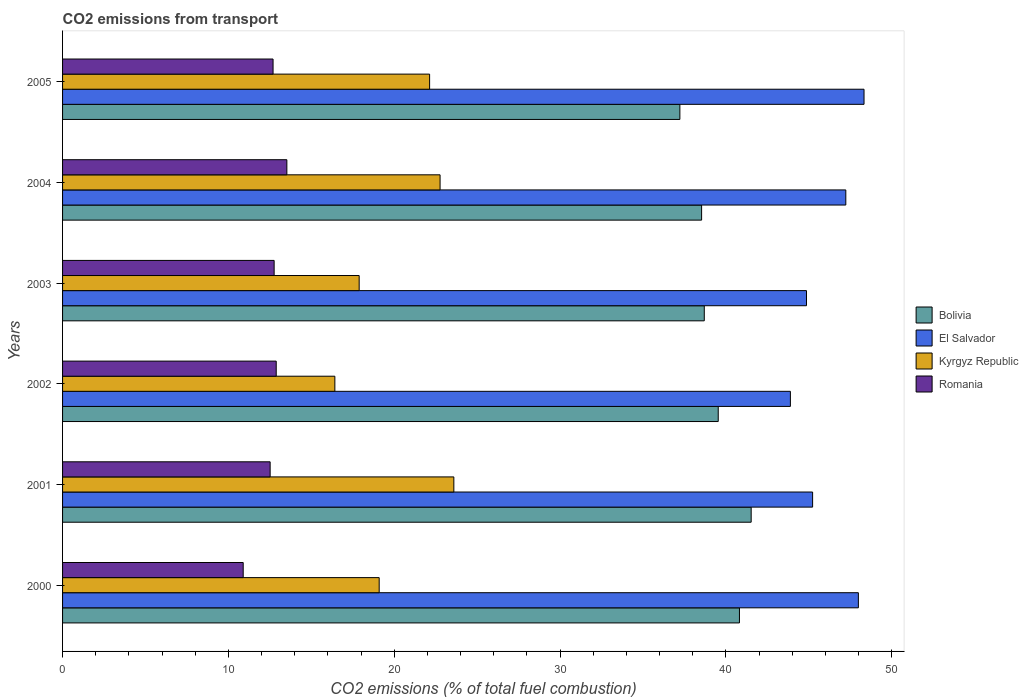How many different coloured bars are there?
Offer a terse response. 4. Are the number of bars per tick equal to the number of legend labels?
Offer a terse response. Yes. Are the number of bars on each tick of the Y-axis equal?
Provide a short and direct response. Yes. How many bars are there on the 6th tick from the top?
Offer a very short reply. 4. What is the label of the 5th group of bars from the top?
Your answer should be very brief. 2001. What is the total CO2 emitted in Romania in 2002?
Offer a terse response. 12.88. Across all years, what is the maximum total CO2 emitted in El Salvador?
Ensure brevity in your answer.  48.33. Across all years, what is the minimum total CO2 emitted in Bolivia?
Offer a terse response. 37.22. What is the total total CO2 emitted in Kyrgyz Republic in the graph?
Your response must be concise. 121.88. What is the difference between the total CO2 emitted in Kyrgyz Republic in 2001 and that in 2005?
Ensure brevity in your answer.  1.46. What is the difference between the total CO2 emitted in Bolivia in 2004 and the total CO2 emitted in Kyrgyz Republic in 2001?
Offer a very short reply. 14.94. What is the average total CO2 emitted in Kyrgyz Republic per year?
Provide a succinct answer. 20.31. In the year 2000, what is the difference between the total CO2 emitted in Kyrgyz Republic and total CO2 emitted in El Salvador?
Your response must be concise. -28.89. In how many years, is the total CO2 emitted in Romania greater than 30 ?
Make the answer very short. 0. What is the ratio of the total CO2 emitted in Bolivia in 2000 to that in 2004?
Keep it short and to the point. 1.06. What is the difference between the highest and the second highest total CO2 emitted in Romania?
Ensure brevity in your answer.  0.64. What is the difference between the highest and the lowest total CO2 emitted in Bolivia?
Ensure brevity in your answer.  4.3. In how many years, is the total CO2 emitted in El Salvador greater than the average total CO2 emitted in El Salvador taken over all years?
Offer a terse response. 3. Is the sum of the total CO2 emitted in Kyrgyz Republic in 2000 and 2003 greater than the maximum total CO2 emitted in El Salvador across all years?
Your response must be concise. No. Is it the case that in every year, the sum of the total CO2 emitted in El Salvador and total CO2 emitted in Romania is greater than the sum of total CO2 emitted in Kyrgyz Republic and total CO2 emitted in Bolivia?
Provide a short and direct response. No. What does the 1st bar from the top in 2004 represents?
Keep it short and to the point. Romania. How many bars are there?
Your answer should be very brief. 24. Does the graph contain grids?
Your answer should be very brief. No. How are the legend labels stacked?
Give a very brief answer. Vertical. What is the title of the graph?
Provide a succinct answer. CO2 emissions from transport. Does "St. Kitts and Nevis" appear as one of the legend labels in the graph?
Offer a terse response. No. What is the label or title of the X-axis?
Keep it short and to the point. CO2 emissions (% of total fuel combustion). What is the label or title of the Y-axis?
Offer a terse response. Years. What is the CO2 emissions (% of total fuel combustion) of Bolivia in 2000?
Make the answer very short. 40.81. What is the CO2 emissions (% of total fuel combustion) in El Salvador in 2000?
Provide a succinct answer. 47.98. What is the CO2 emissions (% of total fuel combustion) in Kyrgyz Republic in 2000?
Ensure brevity in your answer.  19.09. What is the CO2 emissions (% of total fuel combustion) of Romania in 2000?
Your answer should be compact. 10.89. What is the CO2 emissions (% of total fuel combustion) of Bolivia in 2001?
Your answer should be very brief. 41.52. What is the CO2 emissions (% of total fuel combustion) in El Salvador in 2001?
Provide a succinct answer. 45.23. What is the CO2 emissions (% of total fuel combustion) in Kyrgyz Republic in 2001?
Make the answer very short. 23.59. What is the CO2 emissions (% of total fuel combustion) in Romania in 2001?
Provide a short and direct response. 12.52. What is the CO2 emissions (% of total fuel combustion) of Bolivia in 2002?
Provide a short and direct response. 39.53. What is the CO2 emissions (% of total fuel combustion) of El Salvador in 2002?
Make the answer very short. 43.88. What is the CO2 emissions (% of total fuel combustion) of Kyrgyz Republic in 2002?
Your response must be concise. 16.42. What is the CO2 emissions (% of total fuel combustion) of Romania in 2002?
Your answer should be very brief. 12.88. What is the CO2 emissions (% of total fuel combustion) in Bolivia in 2003?
Offer a terse response. 38.69. What is the CO2 emissions (% of total fuel combustion) of El Salvador in 2003?
Keep it short and to the point. 44.86. What is the CO2 emissions (% of total fuel combustion) in Kyrgyz Republic in 2003?
Your response must be concise. 17.88. What is the CO2 emissions (% of total fuel combustion) in Romania in 2003?
Your answer should be compact. 12.76. What is the CO2 emissions (% of total fuel combustion) of Bolivia in 2004?
Ensure brevity in your answer.  38.53. What is the CO2 emissions (% of total fuel combustion) of El Salvador in 2004?
Offer a terse response. 47.23. What is the CO2 emissions (% of total fuel combustion) in Kyrgyz Republic in 2004?
Offer a very short reply. 22.76. What is the CO2 emissions (% of total fuel combustion) in Romania in 2004?
Your answer should be compact. 13.52. What is the CO2 emissions (% of total fuel combustion) in Bolivia in 2005?
Offer a very short reply. 37.22. What is the CO2 emissions (% of total fuel combustion) in El Salvador in 2005?
Keep it short and to the point. 48.33. What is the CO2 emissions (% of total fuel combustion) in Kyrgyz Republic in 2005?
Your answer should be very brief. 22.13. What is the CO2 emissions (% of total fuel combustion) of Romania in 2005?
Offer a very short reply. 12.69. Across all years, what is the maximum CO2 emissions (% of total fuel combustion) of Bolivia?
Provide a succinct answer. 41.52. Across all years, what is the maximum CO2 emissions (% of total fuel combustion) in El Salvador?
Offer a very short reply. 48.33. Across all years, what is the maximum CO2 emissions (% of total fuel combustion) in Kyrgyz Republic?
Your answer should be very brief. 23.59. Across all years, what is the maximum CO2 emissions (% of total fuel combustion) of Romania?
Your answer should be very brief. 13.52. Across all years, what is the minimum CO2 emissions (% of total fuel combustion) of Bolivia?
Make the answer very short. 37.22. Across all years, what is the minimum CO2 emissions (% of total fuel combustion) of El Salvador?
Your response must be concise. 43.88. Across all years, what is the minimum CO2 emissions (% of total fuel combustion) of Kyrgyz Republic?
Your answer should be compact. 16.42. Across all years, what is the minimum CO2 emissions (% of total fuel combustion) in Romania?
Offer a terse response. 10.89. What is the total CO2 emissions (% of total fuel combustion) in Bolivia in the graph?
Provide a short and direct response. 236.32. What is the total CO2 emissions (% of total fuel combustion) in El Salvador in the graph?
Keep it short and to the point. 277.5. What is the total CO2 emissions (% of total fuel combustion) in Kyrgyz Republic in the graph?
Your answer should be very brief. 121.88. What is the total CO2 emissions (% of total fuel combustion) of Romania in the graph?
Offer a terse response. 75.26. What is the difference between the CO2 emissions (% of total fuel combustion) in Bolivia in 2000 and that in 2001?
Provide a short and direct response. -0.71. What is the difference between the CO2 emissions (% of total fuel combustion) in El Salvador in 2000 and that in 2001?
Your answer should be very brief. 2.76. What is the difference between the CO2 emissions (% of total fuel combustion) of Kyrgyz Republic in 2000 and that in 2001?
Give a very brief answer. -4.5. What is the difference between the CO2 emissions (% of total fuel combustion) in Romania in 2000 and that in 2001?
Your answer should be very brief. -1.62. What is the difference between the CO2 emissions (% of total fuel combustion) in Bolivia in 2000 and that in 2002?
Offer a terse response. 1.28. What is the difference between the CO2 emissions (% of total fuel combustion) in El Salvador in 2000 and that in 2002?
Offer a terse response. 4.1. What is the difference between the CO2 emissions (% of total fuel combustion) in Kyrgyz Republic in 2000 and that in 2002?
Your response must be concise. 2.67. What is the difference between the CO2 emissions (% of total fuel combustion) in Romania in 2000 and that in 2002?
Keep it short and to the point. -1.99. What is the difference between the CO2 emissions (% of total fuel combustion) of Bolivia in 2000 and that in 2003?
Ensure brevity in your answer.  2.12. What is the difference between the CO2 emissions (% of total fuel combustion) in El Salvador in 2000 and that in 2003?
Offer a very short reply. 3.13. What is the difference between the CO2 emissions (% of total fuel combustion) of Kyrgyz Republic in 2000 and that in 2003?
Your response must be concise. 1.21. What is the difference between the CO2 emissions (% of total fuel combustion) of Romania in 2000 and that in 2003?
Your answer should be compact. -1.87. What is the difference between the CO2 emissions (% of total fuel combustion) in Bolivia in 2000 and that in 2004?
Keep it short and to the point. 2.28. What is the difference between the CO2 emissions (% of total fuel combustion) of El Salvador in 2000 and that in 2004?
Offer a terse response. 0.76. What is the difference between the CO2 emissions (% of total fuel combustion) in Kyrgyz Republic in 2000 and that in 2004?
Keep it short and to the point. -3.67. What is the difference between the CO2 emissions (% of total fuel combustion) of Romania in 2000 and that in 2004?
Your response must be concise. -2.63. What is the difference between the CO2 emissions (% of total fuel combustion) in Bolivia in 2000 and that in 2005?
Your answer should be very brief. 3.59. What is the difference between the CO2 emissions (% of total fuel combustion) in El Salvador in 2000 and that in 2005?
Your response must be concise. -0.34. What is the difference between the CO2 emissions (% of total fuel combustion) of Kyrgyz Republic in 2000 and that in 2005?
Give a very brief answer. -3.04. What is the difference between the CO2 emissions (% of total fuel combustion) of Romania in 2000 and that in 2005?
Your answer should be very brief. -1.8. What is the difference between the CO2 emissions (% of total fuel combustion) of Bolivia in 2001 and that in 2002?
Your response must be concise. 1.99. What is the difference between the CO2 emissions (% of total fuel combustion) in El Salvador in 2001 and that in 2002?
Give a very brief answer. 1.34. What is the difference between the CO2 emissions (% of total fuel combustion) of Kyrgyz Republic in 2001 and that in 2002?
Give a very brief answer. 7.17. What is the difference between the CO2 emissions (% of total fuel combustion) of Romania in 2001 and that in 2002?
Make the answer very short. -0.37. What is the difference between the CO2 emissions (% of total fuel combustion) in Bolivia in 2001 and that in 2003?
Offer a terse response. 2.83. What is the difference between the CO2 emissions (% of total fuel combustion) of El Salvador in 2001 and that in 2003?
Offer a terse response. 0.37. What is the difference between the CO2 emissions (% of total fuel combustion) in Kyrgyz Republic in 2001 and that in 2003?
Give a very brief answer. 5.71. What is the difference between the CO2 emissions (% of total fuel combustion) in Romania in 2001 and that in 2003?
Your response must be concise. -0.24. What is the difference between the CO2 emissions (% of total fuel combustion) of Bolivia in 2001 and that in 2004?
Offer a terse response. 2.99. What is the difference between the CO2 emissions (% of total fuel combustion) of El Salvador in 2001 and that in 2004?
Give a very brief answer. -2. What is the difference between the CO2 emissions (% of total fuel combustion) in Kyrgyz Republic in 2001 and that in 2004?
Your response must be concise. 0.83. What is the difference between the CO2 emissions (% of total fuel combustion) in Romania in 2001 and that in 2004?
Your response must be concise. -1.01. What is the difference between the CO2 emissions (% of total fuel combustion) of Bolivia in 2001 and that in 2005?
Provide a succinct answer. 4.3. What is the difference between the CO2 emissions (% of total fuel combustion) in El Salvador in 2001 and that in 2005?
Your response must be concise. -3.1. What is the difference between the CO2 emissions (% of total fuel combustion) in Kyrgyz Republic in 2001 and that in 2005?
Your answer should be very brief. 1.46. What is the difference between the CO2 emissions (% of total fuel combustion) in Romania in 2001 and that in 2005?
Make the answer very short. -0.18. What is the difference between the CO2 emissions (% of total fuel combustion) of Bolivia in 2002 and that in 2003?
Ensure brevity in your answer.  0.84. What is the difference between the CO2 emissions (% of total fuel combustion) of El Salvador in 2002 and that in 2003?
Provide a succinct answer. -0.97. What is the difference between the CO2 emissions (% of total fuel combustion) in Kyrgyz Republic in 2002 and that in 2003?
Provide a short and direct response. -1.47. What is the difference between the CO2 emissions (% of total fuel combustion) of Romania in 2002 and that in 2003?
Keep it short and to the point. 0.12. What is the difference between the CO2 emissions (% of total fuel combustion) of El Salvador in 2002 and that in 2004?
Give a very brief answer. -3.34. What is the difference between the CO2 emissions (% of total fuel combustion) of Kyrgyz Republic in 2002 and that in 2004?
Provide a succinct answer. -6.34. What is the difference between the CO2 emissions (% of total fuel combustion) of Romania in 2002 and that in 2004?
Offer a very short reply. -0.64. What is the difference between the CO2 emissions (% of total fuel combustion) in Bolivia in 2002 and that in 2005?
Offer a terse response. 2.31. What is the difference between the CO2 emissions (% of total fuel combustion) in El Salvador in 2002 and that in 2005?
Provide a succinct answer. -4.44. What is the difference between the CO2 emissions (% of total fuel combustion) in Kyrgyz Republic in 2002 and that in 2005?
Ensure brevity in your answer.  -5.71. What is the difference between the CO2 emissions (% of total fuel combustion) of Romania in 2002 and that in 2005?
Your answer should be very brief. 0.19. What is the difference between the CO2 emissions (% of total fuel combustion) in Bolivia in 2003 and that in 2004?
Make the answer very short. 0.16. What is the difference between the CO2 emissions (% of total fuel combustion) of El Salvador in 2003 and that in 2004?
Make the answer very short. -2.37. What is the difference between the CO2 emissions (% of total fuel combustion) of Kyrgyz Republic in 2003 and that in 2004?
Provide a succinct answer. -4.88. What is the difference between the CO2 emissions (% of total fuel combustion) in Romania in 2003 and that in 2004?
Make the answer very short. -0.77. What is the difference between the CO2 emissions (% of total fuel combustion) in Bolivia in 2003 and that in 2005?
Provide a succinct answer. 1.47. What is the difference between the CO2 emissions (% of total fuel combustion) in El Salvador in 2003 and that in 2005?
Ensure brevity in your answer.  -3.47. What is the difference between the CO2 emissions (% of total fuel combustion) of Kyrgyz Republic in 2003 and that in 2005?
Provide a short and direct response. -4.25. What is the difference between the CO2 emissions (% of total fuel combustion) of Romania in 2003 and that in 2005?
Make the answer very short. 0.07. What is the difference between the CO2 emissions (% of total fuel combustion) of Bolivia in 2004 and that in 2005?
Offer a very short reply. 1.31. What is the difference between the CO2 emissions (% of total fuel combustion) of El Salvador in 2004 and that in 2005?
Your answer should be compact. -1.1. What is the difference between the CO2 emissions (% of total fuel combustion) of Kyrgyz Republic in 2004 and that in 2005?
Keep it short and to the point. 0.63. What is the difference between the CO2 emissions (% of total fuel combustion) of Romania in 2004 and that in 2005?
Give a very brief answer. 0.83. What is the difference between the CO2 emissions (% of total fuel combustion) in Bolivia in 2000 and the CO2 emissions (% of total fuel combustion) in El Salvador in 2001?
Your answer should be very brief. -4.41. What is the difference between the CO2 emissions (% of total fuel combustion) of Bolivia in 2000 and the CO2 emissions (% of total fuel combustion) of Kyrgyz Republic in 2001?
Your answer should be compact. 17.22. What is the difference between the CO2 emissions (% of total fuel combustion) of Bolivia in 2000 and the CO2 emissions (% of total fuel combustion) of Romania in 2001?
Your response must be concise. 28.3. What is the difference between the CO2 emissions (% of total fuel combustion) in El Salvador in 2000 and the CO2 emissions (% of total fuel combustion) in Kyrgyz Republic in 2001?
Provide a succinct answer. 24.39. What is the difference between the CO2 emissions (% of total fuel combustion) in El Salvador in 2000 and the CO2 emissions (% of total fuel combustion) in Romania in 2001?
Provide a succinct answer. 35.47. What is the difference between the CO2 emissions (% of total fuel combustion) in Kyrgyz Republic in 2000 and the CO2 emissions (% of total fuel combustion) in Romania in 2001?
Give a very brief answer. 6.57. What is the difference between the CO2 emissions (% of total fuel combustion) in Bolivia in 2000 and the CO2 emissions (% of total fuel combustion) in El Salvador in 2002?
Keep it short and to the point. -3.07. What is the difference between the CO2 emissions (% of total fuel combustion) of Bolivia in 2000 and the CO2 emissions (% of total fuel combustion) of Kyrgyz Republic in 2002?
Your answer should be very brief. 24.4. What is the difference between the CO2 emissions (% of total fuel combustion) of Bolivia in 2000 and the CO2 emissions (% of total fuel combustion) of Romania in 2002?
Your answer should be compact. 27.93. What is the difference between the CO2 emissions (% of total fuel combustion) of El Salvador in 2000 and the CO2 emissions (% of total fuel combustion) of Kyrgyz Republic in 2002?
Give a very brief answer. 31.57. What is the difference between the CO2 emissions (% of total fuel combustion) of El Salvador in 2000 and the CO2 emissions (% of total fuel combustion) of Romania in 2002?
Ensure brevity in your answer.  35.1. What is the difference between the CO2 emissions (% of total fuel combustion) in Kyrgyz Republic in 2000 and the CO2 emissions (% of total fuel combustion) in Romania in 2002?
Your response must be concise. 6.21. What is the difference between the CO2 emissions (% of total fuel combustion) of Bolivia in 2000 and the CO2 emissions (% of total fuel combustion) of El Salvador in 2003?
Give a very brief answer. -4.04. What is the difference between the CO2 emissions (% of total fuel combustion) of Bolivia in 2000 and the CO2 emissions (% of total fuel combustion) of Kyrgyz Republic in 2003?
Your answer should be very brief. 22.93. What is the difference between the CO2 emissions (% of total fuel combustion) of Bolivia in 2000 and the CO2 emissions (% of total fuel combustion) of Romania in 2003?
Provide a succinct answer. 28.06. What is the difference between the CO2 emissions (% of total fuel combustion) in El Salvador in 2000 and the CO2 emissions (% of total fuel combustion) in Kyrgyz Republic in 2003?
Provide a succinct answer. 30.1. What is the difference between the CO2 emissions (% of total fuel combustion) of El Salvador in 2000 and the CO2 emissions (% of total fuel combustion) of Romania in 2003?
Ensure brevity in your answer.  35.23. What is the difference between the CO2 emissions (% of total fuel combustion) in Kyrgyz Republic in 2000 and the CO2 emissions (% of total fuel combustion) in Romania in 2003?
Offer a very short reply. 6.33. What is the difference between the CO2 emissions (% of total fuel combustion) in Bolivia in 2000 and the CO2 emissions (% of total fuel combustion) in El Salvador in 2004?
Your response must be concise. -6.41. What is the difference between the CO2 emissions (% of total fuel combustion) in Bolivia in 2000 and the CO2 emissions (% of total fuel combustion) in Kyrgyz Republic in 2004?
Provide a short and direct response. 18.05. What is the difference between the CO2 emissions (% of total fuel combustion) of Bolivia in 2000 and the CO2 emissions (% of total fuel combustion) of Romania in 2004?
Provide a succinct answer. 27.29. What is the difference between the CO2 emissions (% of total fuel combustion) in El Salvador in 2000 and the CO2 emissions (% of total fuel combustion) in Kyrgyz Republic in 2004?
Offer a very short reply. 25.22. What is the difference between the CO2 emissions (% of total fuel combustion) of El Salvador in 2000 and the CO2 emissions (% of total fuel combustion) of Romania in 2004?
Give a very brief answer. 34.46. What is the difference between the CO2 emissions (% of total fuel combustion) of Kyrgyz Republic in 2000 and the CO2 emissions (% of total fuel combustion) of Romania in 2004?
Offer a very short reply. 5.57. What is the difference between the CO2 emissions (% of total fuel combustion) of Bolivia in 2000 and the CO2 emissions (% of total fuel combustion) of El Salvador in 2005?
Ensure brevity in your answer.  -7.51. What is the difference between the CO2 emissions (% of total fuel combustion) in Bolivia in 2000 and the CO2 emissions (% of total fuel combustion) in Kyrgyz Republic in 2005?
Your answer should be very brief. 18.68. What is the difference between the CO2 emissions (% of total fuel combustion) in Bolivia in 2000 and the CO2 emissions (% of total fuel combustion) in Romania in 2005?
Make the answer very short. 28.12. What is the difference between the CO2 emissions (% of total fuel combustion) in El Salvador in 2000 and the CO2 emissions (% of total fuel combustion) in Kyrgyz Republic in 2005?
Provide a short and direct response. 25.85. What is the difference between the CO2 emissions (% of total fuel combustion) of El Salvador in 2000 and the CO2 emissions (% of total fuel combustion) of Romania in 2005?
Your answer should be very brief. 35.29. What is the difference between the CO2 emissions (% of total fuel combustion) of Kyrgyz Republic in 2000 and the CO2 emissions (% of total fuel combustion) of Romania in 2005?
Your answer should be compact. 6.4. What is the difference between the CO2 emissions (% of total fuel combustion) in Bolivia in 2001 and the CO2 emissions (% of total fuel combustion) in El Salvador in 2002?
Your response must be concise. -2.36. What is the difference between the CO2 emissions (% of total fuel combustion) of Bolivia in 2001 and the CO2 emissions (% of total fuel combustion) of Kyrgyz Republic in 2002?
Your answer should be compact. 25.1. What is the difference between the CO2 emissions (% of total fuel combustion) in Bolivia in 2001 and the CO2 emissions (% of total fuel combustion) in Romania in 2002?
Make the answer very short. 28.64. What is the difference between the CO2 emissions (% of total fuel combustion) in El Salvador in 2001 and the CO2 emissions (% of total fuel combustion) in Kyrgyz Republic in 2002?
Your answer should be very brief. 28.81. What is the difference between the CO2 emissions (% of total fuel combustion) of El Salvador in 2001 and the CO2 emissions (% of total fuel combustion) of Romania in 2002?
Offer a terse response. 32.34. What is the difference between the CO2 emissions (% of total fuel combustion) in Kyrgyz Republic in 2001 and the CO2 emissions (% of total fuel combustion) in Romania in 2002?
Make the answer very short. 10.71. What is the difference between the CO2 emissions (% of total fuel combustion) in Bolivia in 2001 and the CO2 emissions (% of total fuel combustion) in El Salvador in 2003?
Give a very brief answer. -3.34. What is the difference between the CO2 emissions (% of total fuel combustion) in Bolivia in 2001 and the CO2 emissions (% of total fuel combustion) in Kyrgyz Republic in 2003?
Make the answer very short. 23.64. What is the difference between the CO2 emissions (% of total fuel combustion) in Bolivia in 2001 and the CO2 emissions (% of total fuel combustion) in Romania in 2003?
Ensure brevity in your answer.  28.76. What is the difference between the CO2 emissions (% of total fuel combustion) of El Salvador in 2001 and the CO2 emissions (% of total fuel combustion) of Kyrgyz Republic in 2003?
Your answer should be compact. 27.34. What is the difference between the CO2 emissions (% of total fuel combustion) of El Salvador in 2001 and the CO2 emissions (% of total fuel combustion) of Romania in 2003?
Your response must be concise. 32.47. What is the difference between the CO2 emissions (% of total fuel combustion) in Kyrgyz Republic in 2001 and the CO2 emissions (% of total fuel combustion) in Romania in 2003?
Provide a short and direct response. 10.83. What is the difference between the CO2 emissions (% of total fuel combustion) in Bolivia in 2001 and the CO2 emissions (% of total fuel combustion) in El Salvador in 2004?
Ensure brevity in your answer.  -5.71. What is the difference between the CO2 emissions (% of total fuel combustion) of Bolivia in 2001 and the CO2 emissions (% of total fuel combustion) of Kyrgyz Republic in 2004?
Your answer should be very brief. 18.76. What is the difference between the CO2 emissions (% of total fuel combustion) of Bolivia in 2001 and the CO2 emissions (% of total fuel combustion) of Romania in 2004?
Make the answer very short. 28. What is the difference between the CO2 emissions (% of total fuel combustion) in El Salvador in 2001 and the CO2 emissions (% of total fuel combustion) in Kyrgyz Republic in 2004?
Offer a terse response. 22.46. What is the difference between the CO2 emissions (% of total fuel combustion) of El Salvador in 2001 and the CO2 emissions (% of total fuel combustion) of Romania in 2004?
Offer a very short reply. 31.7. What is the difference between the CO2 emissions (% of total fuel combustion) in Kyrgyz Republic in 2001 and the CO2 emissions (% of total fuel combustion) in Romania in 2004?
Your response must be concise. 10.07. What is the difference between the CO2 emissions (% of total fuel combustion) of Bolivia in 2001 and the CO2 emissions (% of total fuel combustion) of El Salvador in 2005?
Provide a short and direct response. -6.8. What is the difference between the CO2 emissions (% of total fuel combustion) in Bolivia in 2001 and the CO2 emissions (% of total fuel combustion) in Kyrgyz Republic in 2005?
Ensure brevity in your answer.  19.39. What is the difference between the CO2 emissions (% of total fuel combustion) of Bolivia in 2001 and the CO2 emissions (% of total fuel combustion) of Romania in 2005?
Your answer should be very brief. 28.83. What is the difference between the CO2 emissions (% of total fuel combustion) of El Salvador in 2001 and the CO2 emissions (% of total fuel combustion) of Kyrgyz Republic in 2005?
Ensure brevity in your answer.  23.09. What is the difference between the CO2 emissions (% of total fuel combustion) in El Salvador in 2001 and the CO2 emissions (% of total fuel combustion) in Romania in 2005?
Your answer should be very brief. 32.53. What is the difference between the CO2 emissions (% of total fuel combustion) in Kyrgyz Republic in 2001 and the CO2 emissions (% of total fuel combustion) in Romania in 2005?
Your answer should be compact. 10.9. What is the difference between the CO2 emissions (% of total fuel combustion) of Bolivia in 2002 and the CO2 emissions (% of total fuel combustion) of El Salvador in 2003?
Ensure brevity in your answer.  -5.32. What is the difference between the CO2 emissions (% of total fuel combustion) in Bolivia in 2002 and the CO2 emissions (% of total fuel combustion) in Kyrgyz Republic in 2003?
Give a very brief answer. 21.65. What is the difference between the CO2 emissions (% of total fuel combustion) of Bolivia in 2002 and the CO2 emissions (% of total fuel combustion) of Romania in 2003?
Keep it short and to the point. 26.78. What is the difference between the CO2 emissions (% of total fuel combustion) of El Salvador in 2002 and the CO2 emissions (% of total fuel combustion) of Kyrgyz Republic in 2003?
Give a very brief answer. 26. What is the difference between the CO2 emissions (% of total fuel combustion) in El Salvador in 2002 and the CO2 emissions (% of total fuel combustion) in Romania in 2003?
Your answer should be very brief. 31.13. What is the difference between the CO2 emissions (% of total fuel combustion) in Kyrgyz Republic in 2002 and the CO2 emissions (% of total fuel combustion) in Romania in 2003?
Give a very brief answer. 3.66. What is the difference between the CO2 emissions (% of total fuel combustion) in Bolivia in 2002 and the CO2 emissions (% of total fuel combustion) in El Salvador in 2004?
Ensure brevity in your answer.  -7.69. What is the difference between the CO2 emissions (% of total fuel combustion) of Bolivia in 2002 and the CO2 emissions (% of total fuel combustion) of Kyrgyz Republic in 2004?
Keep it short and to the point. 16.77. What is the difference between the CO2 emissions (% of total fuel combustion) of Bolivia in 2002 and the CO2 emissions (% of total fuel combustion) of Romania in 2004?
Make the answer very short. 26.01. What is the difference between the CO2 emissions (% of total fuel combustion) of El Salvador in 2002 and the CO2 emissions (% of total fuel combustion) of Kyrgyz Republic in 2004?
Ensure brevity in your answer.  21.12. What is the difference between the CO2 emissions (% of total fuel combustion) in El Salvador in 2002 and the CO2 emissions (% of total fuel combustion) in Romania in 2004?
Your answer should be compact. 30.36. What is the difference between the CO2 emissions (% of total fuel combustion) in Kyrgyz Republic in 2002 and the CO2 emissions (% of total fuel combustion) in Romania in 2004?
Keep it short and to the point. 2.89. What is the difference between the CO2 emissions (% of total fuel combustion) in Bolivia in 2002 and the CO2 emissions (% of total fuel combustion) in El Salvador in 2005?
Provide a succinct answer. -8.79. What is the difference between the CO2 emissions (% of total fuel combustion) of Bolivia in 2002 and the CO2 emissions (% of total fuel combustion) of Kyrgyz Republic in 2005?
Offer a terse response. 17.4. What is the difference between the CO2 emissions (% of total fuel combustion) in Bolivia in 2002 and the CO2 emissions (% of total fuel combustion) in Romania in 2005?
Offer a very short reply. 26.84. What is the difference between the CO2 emissions (% of total fuel combustion) in El Salvador in 2002 and the CO2 emissions (% of total fuel combustion) in Kyrgyz Republic in 2005?
Offer a terse response. 21.75. What is the difference between the CO2 emissions (% of total fuel combustion) in El Salvador in 2002 and the CO2 emissions (% of total fuel combustion) in Romania in 2005?
Offer a terse response. 31.19. What is the difference between the CO2 emissions (% of total fuel combustion) in Kyrgyz Republic in 2002 and the CO2 emissions (% of total fuel combustion) in Romania in 2005?
Ensure brevity in your answer.  3.73. What is the difference between the CO2 emissions (% of total fuel combustion) in Bolivia in 2003 and the CO2 emissions (% of total fuel combustion) in El Salvador in 2004?
Your response must be concise. -8.53. What is the difference between the CO2 emissions (% of total fuel combustion) in Bolivia in 2003 and the CO2 emissions (% of total fuel combustion) in Kyrgyz Republic in 2004?
Keep it short and to the point. 15.93. What is the difference between the CO2 emissions (% of total fuel combustion) in Bolivia in 2003 and the CO2 emissions (% of total fuel combustion) in Romania in 2004?
Give a very brief answer. 25.17. What is the difference between the CO2 emissions (% of total fuel combustion) in El Salvador in 2003 and the CO2 emissions (% of total fuel combustion) in Kyrgyz Republic in 2004?
Your answer should be compact. 22.09. What is the difference between the CO2 emissions (% of total fuel combustion) of El Salvador in 2003 and the CO2 emissions (% of total fuel combustion) of Romania in 2004?
Provide a short and direct response. 31.33. What is the difference between the CO2 emissions (% of total fuel combustion) of Kyrgyz Republic in 2003 and the CO2 emissions (% of total fuel combustion) of Romania in 2004?
Keep it short and to the point. 4.36. What is the difference between the CO2 emissions (% of total fuel combustion) of Bolivia in 2003 and the CO2 emissions (% of total fuel combustion) of El Salvador in 2005?
Ensure brevity in your answer.  -9.63. What is the difference between the CO2 emissions (% of total fuel combustion) of Bolivia in 2003 and the CO2 emissions (% of total fuel combustion) of Kyrgyz Republic in 2005?
Offer a terse response. 16.56. What is the difference between the CO2 emissions (% of total fuel combustion) in Bolivia in 2003 and the CO2 emissions (% of total fuel combustion) in Romania in 2005?
Keep it short and to the point. 26. What is the difference between the CO2 emissions (% of total fuel combustion) in El Salvador in 2003 and the CO2 emissions (% of total fuel combustion) in Kyrgyz Republic in 2005?
Keep it short and to the point. 22.73. What is the difference between the CO2 emissions (% of total fuel combustion) in El Salvador in 2003 and the CO2 emissions (% of total fuel combustion) in Romania in 2005?
Ensure brevity in your answer.  32.16. What is the difference between the CO2 emissions (% of total fuel combustion) in Kyrgyz Republic in 2003 and the CO2 emissions (% of total fuel combustion) in Romania in 2005?
Your response must be concise. 5.19. What is the difference between the CO2 emissions (% of total fuel combustion) in Bolivia in 2004 and the CO2 emissions (% of total fuel combustion) in El Salvador in 2005?
Keep it short and to the point. -9.79. What is the difference between the CO2 emissions (% of total fuel combustion) in Bolivia in 2004 and the CO2 emissions (% of total fuel combustion) in Kyrgyz Republic in 2005?
Keep it short and to the point. 16.4. What is the difference between the CO2 emissions (% of total fuel combustion) in Bolivia in 2004 and the CO2 emissions (% of total fuel combustion) in Romania in 2005?
Your answer should be compact. 25.84. What is the difference between the CO2 emissions (% of total fuel combustion) in El Salvador in 2004 and the CO2 emissions (% of total fuel combustion) in Kyrgyz Republic in 2005?
Offer a terse response. 25.1. What is the difference between the CO2 emissions (% of total fuel combustion) of El Salvador in 2004 and the CO2 emissions (% of total fuel combustion) of Romania in 2005?
Offer a terse response. 34.53. What is the difference between the CO2 emissions (% of total fuel combustion) of Kyrgyz Republic in 2004 and the CO2 emissions (% of total fuel combustion) of Romania in 2005?
Give a very brief answer. 10.07. What is the average CO2 emissions (% of total fuel combustion) of Bolivia per year?
Your response must be concise. 39.39. What is the average CO2 emissions (% of total fuel combustion) of El Salvador per year?
Offer a terse response. 46.25. What is the average CO2 emissions (% of total fuel combustion) in Kyrgyz Republic per year?
Your answer should be very brief. 20.31. What is the average CO2 emissions (% of total fuel combustion) of Romania per year?
Make the answer very short. 12.54. In the year 2000, what is the difference between the CO2 emissions (% of total fuel combustion) in Bolivia and CO2 emissions (% of total fuel combustion) in El Salvador?
Offer a terse response. -7.17. In the year 2000, what is the difference between the CO2 emissions (% of total fuel combustion) in Bolivia and CO2 emissions (% of total fuel combustion) in Kyrgyz Republic?
Offer a very short reply. 21.72. In the year 2000, what is the difference between the CO2 emissions (% of total fuel combustion) in Bolivia and CO2 emissions (% of total fuel combustion) in Romania?
Keep it short and to the point. 29.92. In the year 2000, what is the difference between the CO2 emissions (% of total fuel combustion) of El Salvador and CO2 emissions (% of total fuel combustion) of Kyrgyz Republic?
Keep it short and to the point. 28.89. In the year 2000, what is the difference between the CO2 emissions (% of total fuel combustion) in El Salvador and CO2 emissions (% of total fuel combustion) in Romania?
Ensure brevity in your answer.  37.09. In the year 2000, what is the difference between the CO2 emissions (% of total fuel combustion) of Kyrgyz Republic and CO2 emissions (% of total fuel combustion) of Romania?
Offer a very short reply. 8.2. In the year 2001, what is the difference between the CO2 emissions (% of total fuel combustion) of Bolivia and CO2 emissions (% of total fuel combustion) of El Salvador?
Your answer should be very brief. -3.7. In the year 2001, what is the difference between the CO2 emissions (% of total fuel combustion) of Bolivia and CO2 emissions (% of total fuel combustion) of Kyrgyz Republic?
Your response must be concise. 17.93. In the year 2001, what is the difference between the CO2 emissions (% of total fuel combustion) of Bolivia and CO2 emissions (% of total fuel combustion) of Romania?
Ensure brevity in your answer.  29. In the year 2001, what is the difference between the CO2 emissions (% of total fuel combustion) in El Salvador and CO2 emissions (% of total fuel combustion) in Kyrgyz Republic?
Your response must be concise. 21.63. In the year 2001, what is the difference between the CO2 emissions (% of total fuel combustion) in El Salvador and CO2 emissions (% of total fuel combustion) in Romania?
Your answer should be very brief. 32.71. In the year 2001, what is the difference between the CO2 emissions (% of total fuel combustion) in Kyrgyz Republic and CO2 emissions (% of total fuel combustion) in Romania?
Make the answer very short. 11.08. In the year 2002, what is the difference between the CO2 emissions (% of total fuel combustion) in Bolivia and CO2 emissions (% of total fuel combustion) in El Salvador?
Give a very brief answer. -4.35. In the year 2002, what is the difference between the CO2 emissions (% of total fuel combustion) of Bolivia and CO2 emissions (% of total fuel combustion) of Kyrgyz Republic?
Your response must be concise. 23.12. In the year 2002, what is the difference between the CO2 emissions (% of total fuel combustion) in Bolivia and CO2 emissions (% of total fuel combustion) in Romania?
Your response must be concise. 26.65. In the year 2002, what is the difference between the CO2 emissions (% of total fuel combustion) in El Salvador and CO2 emissions (% of total fuel combustion) in Kyrgyz Republic?
Provide a succinct answer. 27.47. In the year 2002, what is the difference between the CO2 emissions (% of total fuel combustion) in El Salvador and CO2 emissions (% of total fuel combustion) in Romania?
Provide a short and direct response. 31. In the year 2002, what is the difference between the CO2 emissions (% of total fuel combustion) in Kyrgyz Republic and CO2 emissions (% of total fuel combustion) in Romania?
Give a very brief answer. 3.54. In the year 2003, what is the difference between the CO2 emissions (% of total fuel combustion) of Bolivia and CO2 emissions (% of total fuel combustion) of El Salvador?
Keep it short and to the point. -6.16. In the year 2003, what is the difference between the CO2 emissions (% of total fuel combustion) of Bolivia and CO2 emissions (% of total fuel combustion) of Kyrgyz Republic?
Your answer should be very brief. 20.81. In the year 2003, what is the difference between the CO2 emissions (% of total fuel combustion) of Bolivia and CO2 emissions (% of total fuel combustion) of Romania?
Your answer should be very brief. 25.94. In the year 2003, what is the difference between the CO2 emissions (% of total fuel combustion) in El Salvador and CO2 emissions (% of total fuel combustion) in Kyrgyz Republic?
Make the answer very short. 26.97. In the year 2003, what is the difference between the CO2 emissions (% of total fuel combustion) in El Salvador and CO2 emissions (% of total fuel combustion) in Romania?
Make the answer very short. 32.1. In the year 2003, what is the difference between the CO2 emissions (% of total fuel combustion) of Kyrgyz Republic and CO2 emissions (% of total fuel combustion) of Romania?
Ensure brevity in your answer.  5.13. In the year 2004, what is the difference between the CO2 emissions (% of total fuel combustion) of Bolivia and CO2 emissions (% of total fuel combustion) of El Salvador?
Your answer should be very brief. -8.69. In the year 2004, what is the difference between the CO2 emissions (% of total fuel combustion) in Bolivia and CO2 emissions (% of total fuel combustion) in Kyrgyz Republic?
Ensure brevity in your answer.  15.77. In the year 2004, what is the difference between the CO2 emissions (% of total fuel combustion) in Bolivia and CO2 emissions (% of total fuel combustion) in Romania?
Give a very brief answer. 25.01. In the year 2004, what is the difference between the CO2 emissions (% of total fuel combustion) of El Salvador and CO2 emissions (% of total fuel combustion) of Kyrgyz Republic?
Your response must be concise. 24.46. In the year 2004, what is the difference between the CO2 emissions (% of total fuel combustion) in El Salvador and CO2 emissions (% of total fuel combustion) in Romania?
Give a very brief answer. 33.7. In the year 2004, what is the difference between the CO2 emissions (% of total fuel combustion) in Kyrgyz Republic and CO2 emissions (% of total fuel combustion) in Romania?
Make the answer very short. 9.24. In the year 2005, what is the difference between the CO2 emissions (% of total fuel combustion) of Bolivia and CO2 emissions (% of total fuel combustion) of El Salvador?
Ensure brevity in your answer.  -11.1. In the year 2005, what is the difference between the CO2 emissions (% of total fuel combustion) of Bolivia and CO2 emissions (% of total fuel combustion) of Kyrgyz Republic?
Provide a short and direct response. 15.09. In the year 2005, what is the difference between the CO2 emissions (% of total fuel combustion) of Bolivia and CO2 emissions (% of total fuel combustion) of Romania?
Offer a terse response. 24.53. In the year 2005, what is the difference between the CO2 emissions (% of total fuel combustion) of El Salvador and CO2 emissions (% of total fuel combustion) of Kyrgyz Republic?
Offer a very short reply. 26.19. In the year 2005, what is the difference between the CO2 emissions (% of total fuel combustion) in El Salvador and CO2 emissions (% of total fuel combustion) in Romania?
Offer a very short reply. 35.63. In the year 2005, what is the difference between the CO2 emissions (% of total fuel combustion) in Kyrgyz Republic and CO2 emissions (% of total fuel combustion) in Romania?
Offer a very short reply. 9.44. What is the ratio of the CO2 emissions (% of total fuel combustion) in Bolivia in 2000 to that in 2001?
Provide a succinct answer. 0.98. What is the ratio of the CO2 emissions (% of total fuel combustion) in El Salvador in 2000 to that in 2001?
Offer a very short reply. 1.06. What is the ratio of the CO2 emissions (% of total fuel combustion) of Kyrgyz Republic in 2000 to that in 2001?
Provide a succinct answer. 0.81. What is the ratio of the CO2 emissions (% of total fuel combustion) of Romania in 2000 to that in 2001?
Ensure brevity in your answer.  0.87. What is the ratio of the CO2 emissions (% of total fuel combustion) of Bolivia in 2000 to that in 2002?
Provide a short and direct response. 1.03. What is the ratio of the CO2 emissions (% of total fuel combustion) in El Salvador in 2000 to that in 2002?
Ensure brevity in your answer.  1.09. What is the ratio of the CO2 emissions (% of total fuel combustion) of Kyrgyz Republic in 2000 to that in 2002?
Provide a succinct answer. 1.16. What is the ratio of the CO2 emissions (% of total fuel combustion) in Romania in 2000 to that in 2002?
Offer a terse response. 0.85. What is the ratio of the CO2 emissions (% of total fuel combustion) in Bolivia in 2000 to that in 2003?
Offer a very short reply. 1.05. What is the ratio of the CO2 emissions (% of total fuel combustion) in El Salvador in 2000 to that in 2003?
Keep it short and to the point. 1.07. What is the ratio of the CO2 emissions (% of total fuel combustion) of Kyrgyz Republic in 2000 to that in 2003?
Provide a succinct answer. 1.07. What is the ratio of the CO2 emissions (% of total fuel combustion) in Romania in 2000 to that in 2003?
Ensure brevity in your answer.  0.85. What is the ratio of the CO2 emissions (% of total fuel combustion) in Bolivia in 2000 to that in 2004?
Give a very brief answer. 1.06. What is the ratio of the CO2 emissions (% of total fuel combustion) in El Salvador in 2000 to that in 2004?
Your response must be concise. 1.02. What is the ratio of the CO2 emissions (% of total fuel combustion) of Kyrgyz Republic in 2000 to that in 2004?
Ensure brevity in your answer.  0.84. What is the ratio of the CO2 emissions (% of total fuel combustion) of Romania in 2000 to that in 2004?
Give a very brief answer. 0.81. What is the ratio of the CO2 emissions (% of total fuel combustion) in Bolivia in 2000 to that in 2005?
Make the answer very short. 1.1. What is the ratio of the CO2 emissions (% of total fuel combustion) of Kyrgyz Republic in 2000 to that in 2005?
Keep it short and to the point. 0.86. What is the ratio of the CO2 emissions (% of total fuel combustion) of Romania in 2000 to that in 2005?
Offer a very short reply. 0.86. What is the ratio of the CO2 emissions (% of total fuel combustion) in Bolivia in 2001 to that in 2002?
Your answer should be compact. 1.05. What is the ratio of the CO2 emissions (% of total fuel combustion) in El Salvador in 2001 to that in 2002?
Your answer should be compact. 1.03. What is the ratio of the CO2 emissions (% of total fuel combustion) in Kyrgyz Republic in 2001 to that in 2002?
Provide a short and direct response. 1.44. What is the ratio of the CO2 emissions (% of total fuel combustion) of Romania in 2001 to that in 2002?
Provide a succinct answer. 0.97. What is the ratio of the CO2 emissions (% of total fuel combustion) in Bolivia in 2001 to that in 2003?
Give a very brief answer. 1.07. What is the ratio of the CO2 emissions (% of total fuel combustion) in El Salvador in 2001 to that in 2003?
Provide a succinct answer. 1.01. What is the ratio of the CO2 emissions (% of total fuel combustion) in Kyrgyz Republic in 2001 to that in 2003?
Offer a very short reply. 1.32. What is the ratio of the CO2 emissions (% of total fuel combustion) in Romania in 2001 to that in 2003?
Ensure brevity in your answer.  0.98. What is the ratio of the CO2 emissions (% of total fuel combustion) of Bolivia in 2001 to that in 2004?
Give a very brief answer. 1.08. What is the ratio of the CO2 emissions (% of total fuel combustion) of El Salvador in 2001 to that in 2004?
Offer a terse response. 0.96. What is the ratio of the CO2 emissions (% of total fuel combustion) of Kyrgyz Republic in 2001 to that in 2004?
Give a very brief answer. 1.04. What is the ratio of the CO2 emissions (% of total fuel combustion) of Romania in 2001 to that in 2004?
Your answer should be very brief. 0.93. What is the ratio of the CO2 emissions (% of total fuel combustion) in Bolivia in 2001 to that in 2005?
Ensure brevity in your answer.  1.12. What is the ratio of the CO2 emissions (% of total fuel combustion) of El Salvador in 2001 to that in 2005?
Ensure brevity in your answer.  0.94. What is the ratio of the CO2 emissions (% of total fuel combustion) of Kyrgyz Republic in 2001 to that in 2005?
Your answer should be very brief. 1.07. What is the ratio of the CO2 emissions (% of total fuel combustion) of Romania in 2001 to that in 2005?
Your answer should be very brief. 0.99. What is the ratio of the CO2 emissions (% of total fuel combustion) of Bolivia in 2002 to that in 2003?
Give a very brief answer. 1.02. What is the ratio of the CO2 emissions (% of total fuel combustion) in El Salvador in 2002 to that in 2003?
Your response must be concise. 0.98. What is the ratio of the CO2 emissions (% of total fuel combustion) in Kyrgyz Republic in 2002 to that in 2003?
Keep it short and to the point. 0.92. What is the ratio of the CO2 emissions (% of total fuel combustion) of Romania in 2002 to that in 2003?
Keep it short and to the point. 1.01. What is the ratio of the CO2 emissions (% of total fuel combustion) in Bolivia in 2002 to that in 2004?
Provide a succinct answer. 1.03. What is the ratio of the CO2 emissions (% of total fuel combustion) in El Salvador in 2002 to that in 2004?
Your answer should be compact. 0.93. What is the ratio of the CO2 emissions (% of total fuel combustion) in Kyrgyz Republic in 2002 to that in 2004?
Ensure brevity in your answer.  0.72. What is the ratio of the CO2 emissions (% of total fuel combustion) of Romania in 2002 to that in 2004?
Your answer should be compact. 0.95. What is the ratio of the CO2 emissions (% of total fuel combustion) in Bolivia in 2002 to that in 2005?
Provide a short and direct response. 1.06. What is the ratio of the CO2 emissions (% of total fuel combustion) of El Salvador in 2002 to that in 2005?
Give a very brief answer. 0.91. What is the ratio of the CO2 emissions (% of total fuel combustion) in Kyrgyz Republic in 2002 to that in 2005?
Ensure brevity in your answer.  0.74. What is the ratio of the CO2 emissions (% of total fuel combustion) in Romania in 2002 to that in 2005?
Provide a succinct answer. 1.01. What is the ratio of the CO2 emissions (% of total fuel combustion) in Bolivia in 2003 to that in 2004?
Your response must be concise. 1. What is the ratio of the CO2 emissions (% of total fuel combustion) in El Salvador in 2003 to that in 2004?
Your answer should be compact. 0.95. What is the ratio of the CO2 emissions (% of total fuel combustion) of Kyrgyz Republic in 2003 to that in 2004?
Ensure brevity in your answer.  0.79. What is the ratio of the CO2 emissions (% of total fuel combustion) of Romania in 2003 to that in 2004?
Your answer should be very brief. 0.94. What is the ratio of the CO2 emissions (% of total fuel combustion) in Bolivia in 2003 to that in 2005?
Your response must be concise. 1.04. What is the ratio of the CO2 emissions (% of total fuel combustion) of El Salvador in 2003 to that in 2005?
Offer a very short reply. 0.93. What is the ratio of the CO2 emissions (% of total fuel combustion) in Kyrgyz Republic in 2003 to that in 2005?
Offer a terse response. 0.81. What is the ratio of the CO2 emissions (% of total fuel combustion) in Bolivia in 2004 to that in 2005?
Your answer should be very brief. 1.04. What is the ratio of the CO2 emissions (% of total fuel combustion) of El Salvador in 2004 to that in 2005?
Provide a succinct answer. 0.98. What is the ratio of the CO2 emissions (% of total fuel combustion) of Kyrgyz Republic in 2004 to that in 2005?
Offer a very short reply. 1.03. What is the ratio of the CO2 emissions (% of total fuel combustion) of Romania in 2004 to that in 2005?
Keep it short and to the point. 1.07. What is the difference between the highest and the second highest CO2 emissions (% of total fuel combustion) in Bolivia?
Provide a succinct answer. 0.71. What is the difference between the highest and the second highest CO2 emissions (% of total fuel combustion) in El Salvador?
Give a very brief answer. 0.34. What is the difference between the highest and the second highest CO2 emissions (% of total fuel combustion) in Kyrgyz Republic?
Provide a succinct answer. 0.83. What is the difference between the highest and the second highest CO2 emissions (% of total fuel combustion) in Romania?
Ensure brevity in your answer.  0.64. What is the difference between the highest and the lowest CO2 emissions (% of total fuel combustion) of Bolivia?
Your response must be concise. 4.3. What is the difference between the highest and the lowest CO2 emissions (% of total fuel combustion) of El Salvador?
Ensure brevity in your answer.  4.44. What is the difference between the highest and the lowest CO2 emissions (% of total fuel combustion) in Kyrgyz Republic?
Provide a succinct answer. 7.17. What is the difference between the highest and the lowest CO2 emissions (% of total fuel combustion) in Romania?
Offer a terse response. 2.63. 